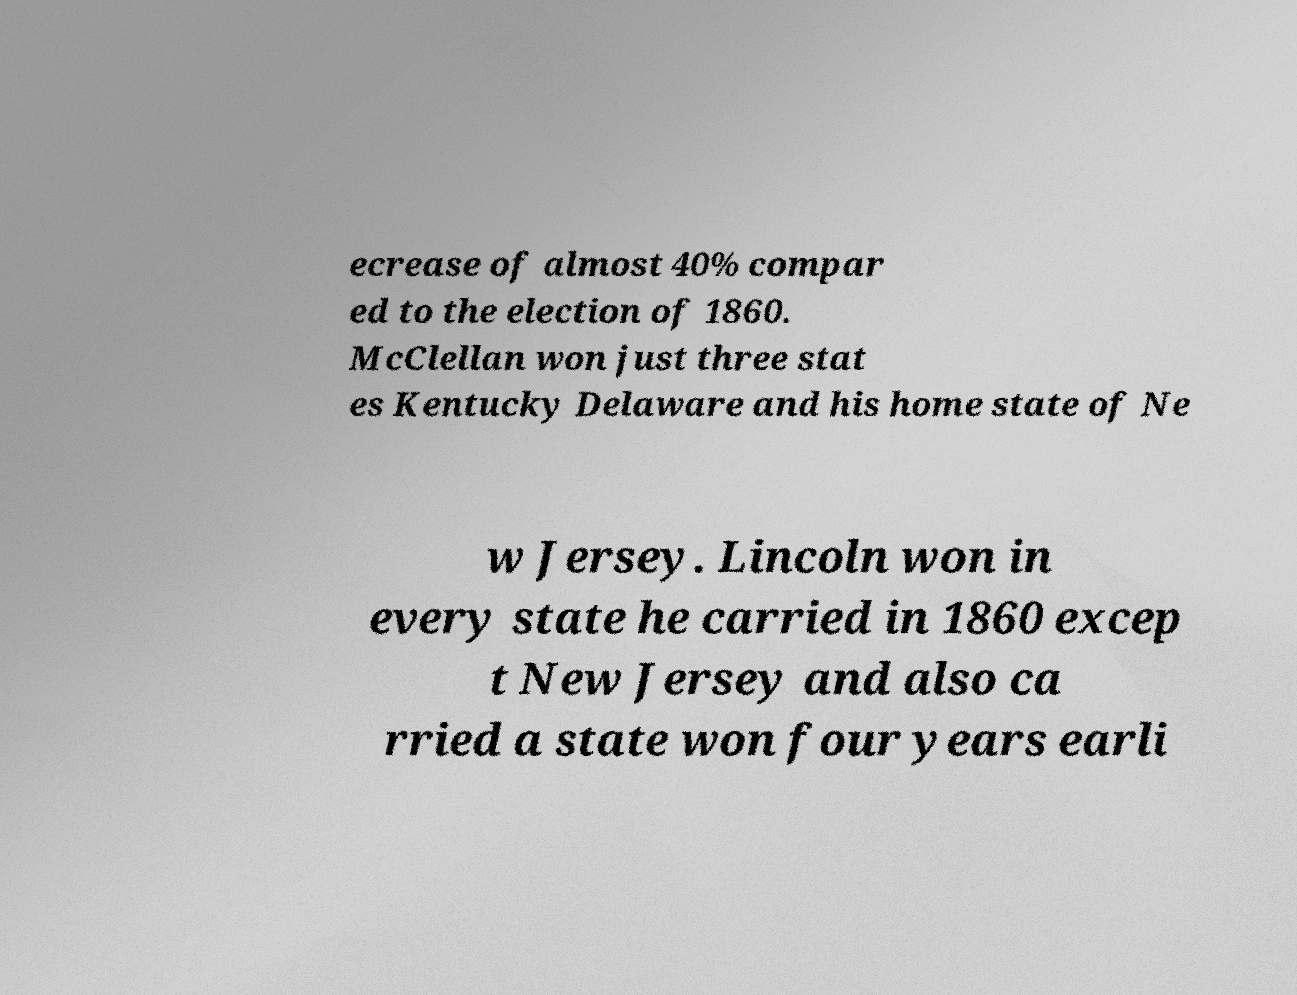What messages or text are displayed in this image? I need them in a readable, typed format. ecrease of almost 40% compar ed to the election of 1860. McClellan won just three stat es Kentucky Delaware and his home state of Ne w Jersey. Lincoln won in every state he carried in 1860 excep t New Jersey and also ca rried a state won four years earli 